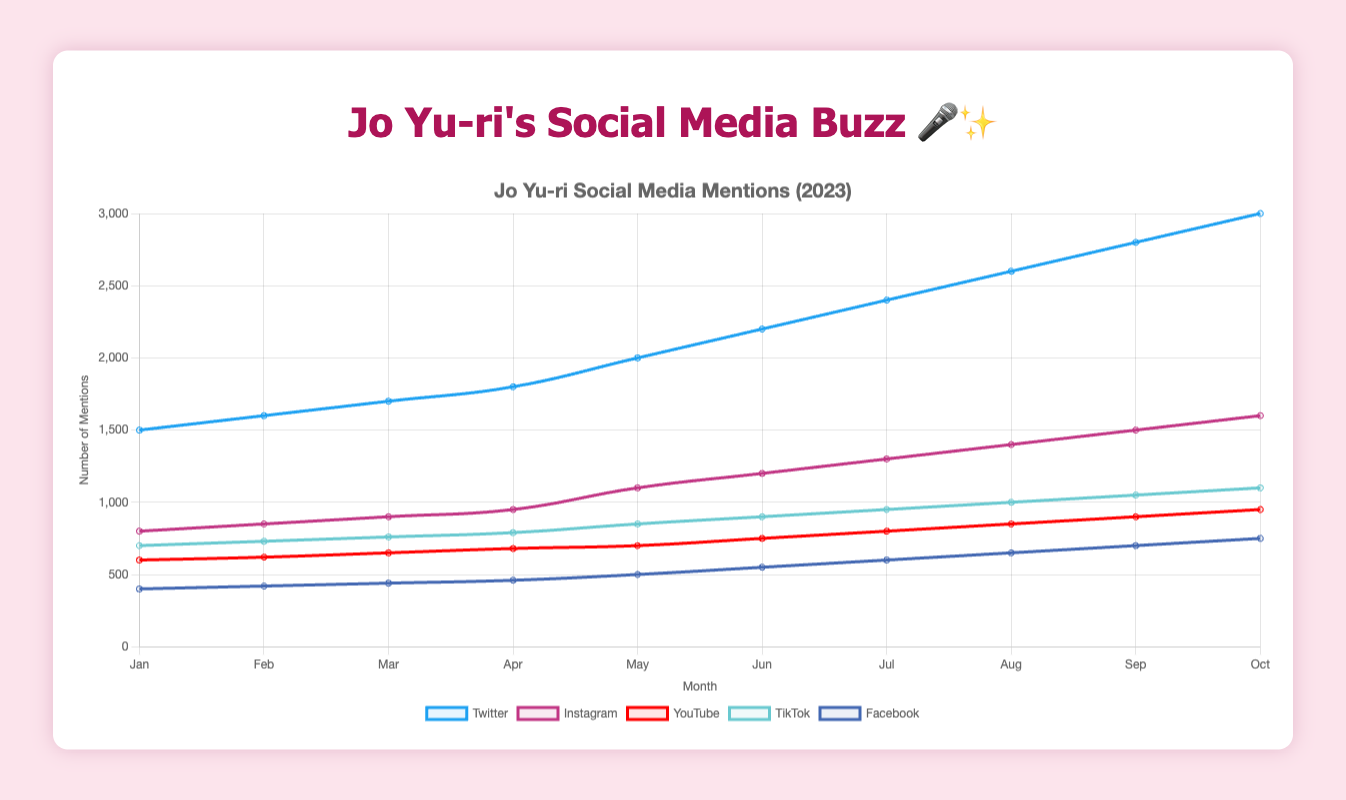Which social media platform has the highest mentions in October 2023? The figure shows multiple lines representing each platform's mentions over time. In October 2023, the highest line corresponds to Twitter.
Answer: Twitter How many more mentions did Jo Yu-ri have on TikTok in June compared to March 2023? In March, TikTok mentions were 760, and in June, they were 900. The difference is 900 - 760 = 140 mentions.
Answer: 140 Which month shows the greatest increase in Twitter mentions compared to the previous month? Comparing the increases month by month, the jump from April (1800 mentions) to May (2000 mentions) is 200 mentions, which is the highest increase.
Answer: May What’s the average number of Instagram mentions in the first half of 2023? The mentions are: January - 800, February - 850, March - 900, April - 950, May - 1100, June - 1200. Average = (800 + 850 + 900 + 950 + 1100 + 1200) / 6 = 8000 / 6 = 950.
Answer: 950 What is the percentage increase in YouTube mentions from January to October 2023? In January, YouTube mentions were 600, and in October, they were 950. Percentage increase = [(950 - 600) / 600] * 100 = (350 / 600) * 100 = 58.33%.
Answer: 58.33% Which platform shows a steady linear increase in mentions across 2023? Observing the trend lines, Facebook shows a consistent increase each month without sharp jolts, indicating a steady linear increase.
Answer: Facebook How does the number of Instagram mentions in August compare to those in March 2023? In March, Instagram mentions were 900, and in August, they were 1400. The increase is 1400 - 900 = 500 mentions.
Answer: 500 What's the sum of mentions from all platforms in October 2023? Sum of mentions in October: Twitter (3000) + Instagram (1600) + YouTube (950) + TikTok (1100) + Facebook (750) = 7400.
Answer: 7400 What's the median value of Twitter mentions from January to October 2023? Sorting the Twitter mentions: [1500, 1600, 1700, 1800, 2000, 2200, 2400, 2600, 2800, 3000]. The median is the average of the 5th and 6th values: (2000 + 2200) / 2 = 2100.
Answer: 2100 